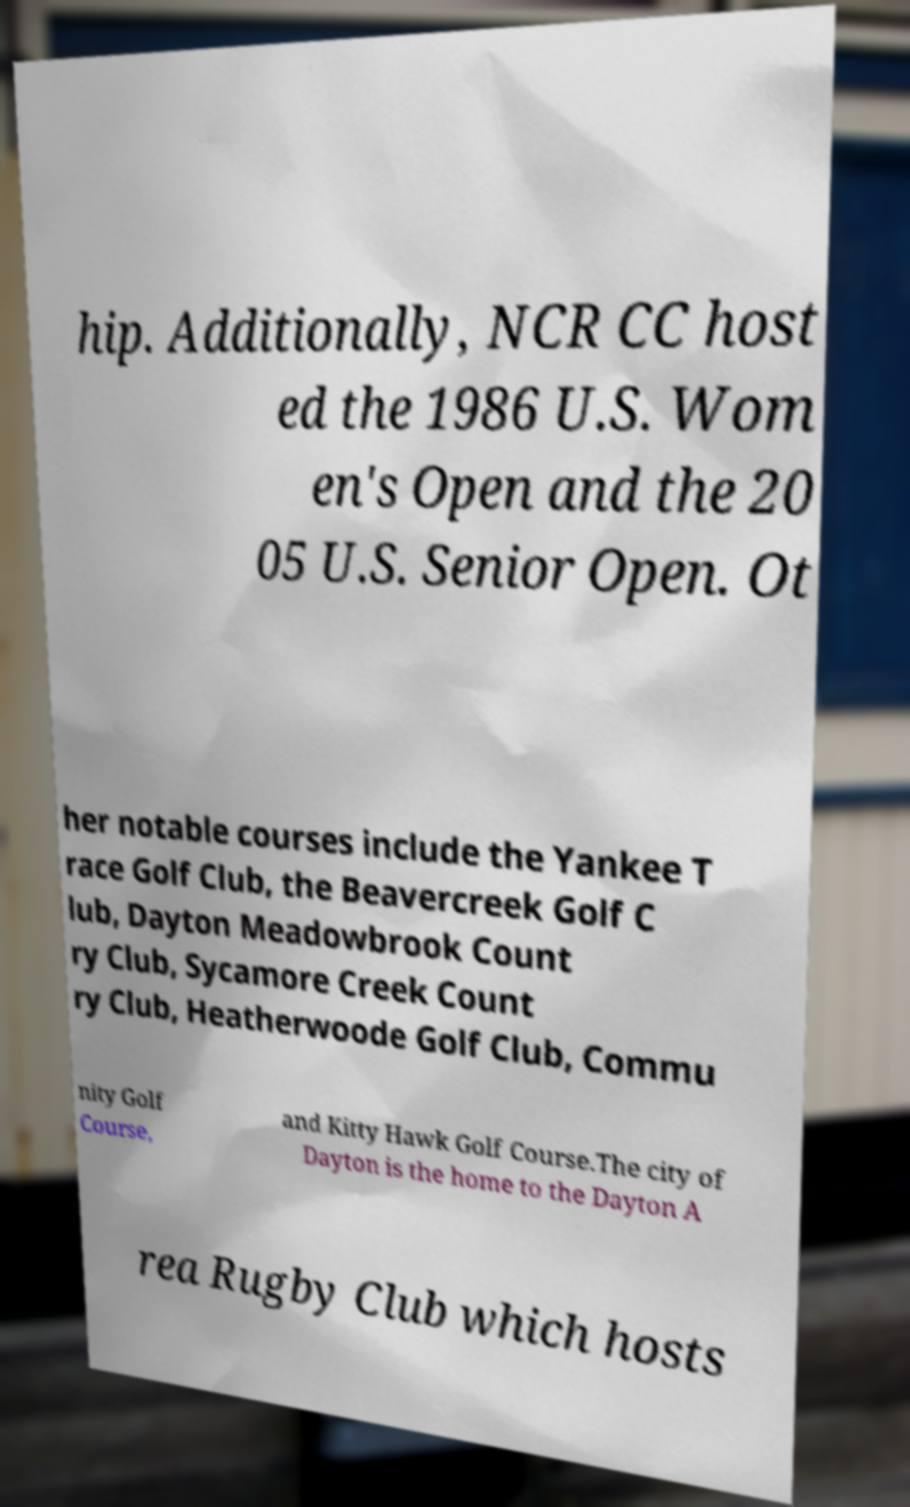Can you accurately transcribe the text from the provided image for me? hip. Additionally, NCR CC host ed the 1986 U.S. Wom en's Open and the 20 05 U.S. Senior Open. Ot her notable courses include the Yankee T race Golf Club, the Beavercreek Golf C lub, Dayton Meadowbrook Count ry Club, Sycamore Creek Count ry Club, Heatherwoode Golf Club, Commu nity Golf Course, and Kitty Hawk Golf Course.The city of Dayton is the home to the Dayton A rea Rugby Club which hosts 